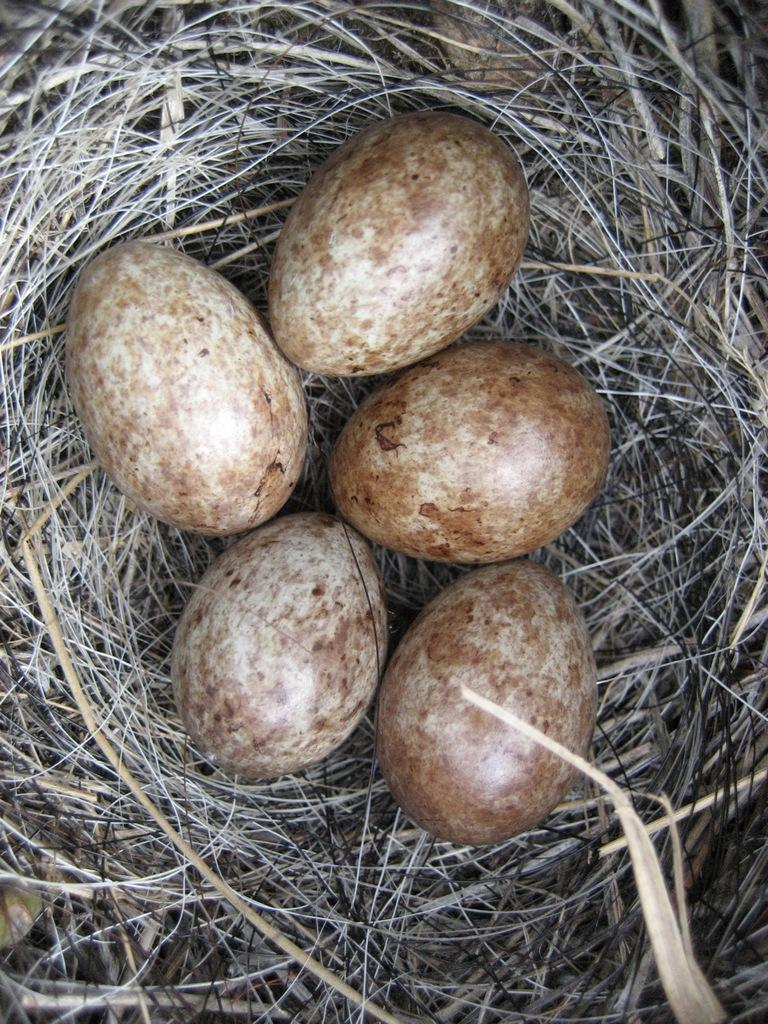What can be seen in the image that is related to birds? There is a nest in the image. How many eggs are present in the nest? There are five eggs in the nest. What channel is the nest located on in the image? The image does not depict a television channel, so there is no channel present. What is the monetary value of the eggs in the nest? The value of the eggs cannot be determined from the image, as they are not being sold or traded. 